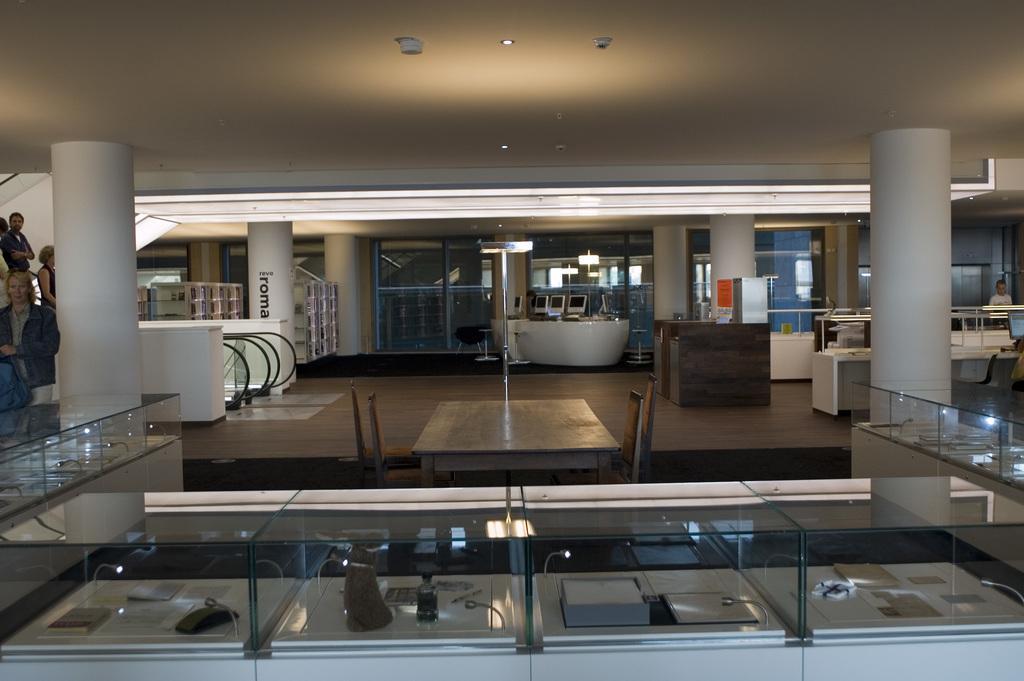Could you give a brief overview of what you see in this image? In this image we can see platforms with glass boxes. Inside that there are few items. In the back there are pillars, escalators and few people. In the background there are glass walls, wooden objects and stools. 